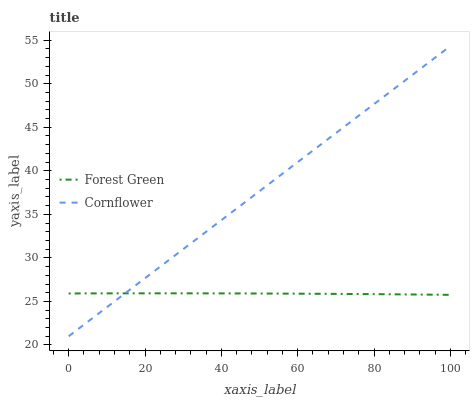Does Forest Green have the minimum area under the curve?
Answer yes or no. Yes. Does Cornflower have the maximum area under the curve?
Answer yes or no. Yes. Does Forest Green have the maximum area under the curve?
Answer yes or no. No. Is Cornflower the smoothest?
Answer yes or no. Yes. Is Forest Green the roughest?
Answer yes or no. Yes. Is Forest Green the smoothest?
Answer yes or no. No. Does Cornflower have the lowest value?
Answer yes or no. Yes. Does Forest Green have the lowest value?
Answer yes or no. No. Does Cornflower have the highest value?
Answer yes or no. Yes. Does Forest Green have the highest value?
Answer yes or no. No. Does Cornflower intersect Forest Green?
Answer yes or no. Yes. Is Cornflower less than Forest Green?
Answer yes or no. No. Is Cornflower greater than Forest Green?
Answer yes or no. No. 